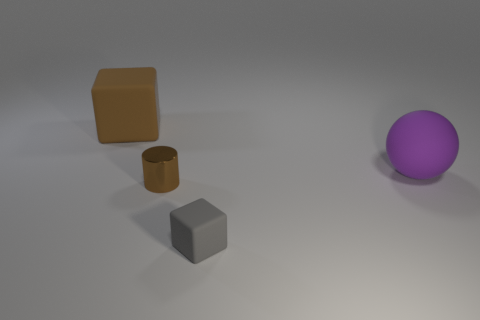Add 4 green rubber cylinders. How many objects exist? 8 Subtract all spheres. How many objects are left? 3 Add 1 purple matte objects. How many purple matte objects are left? 2 Add 1 tiny brown shiny things. How many tiny brown shiny things exist? 2 Subtract 0 purple cylinders. How many objects are left? 4 Subtract all tiny yellow shiny spheres. Subtract all big objects. How many objects are left? 2 